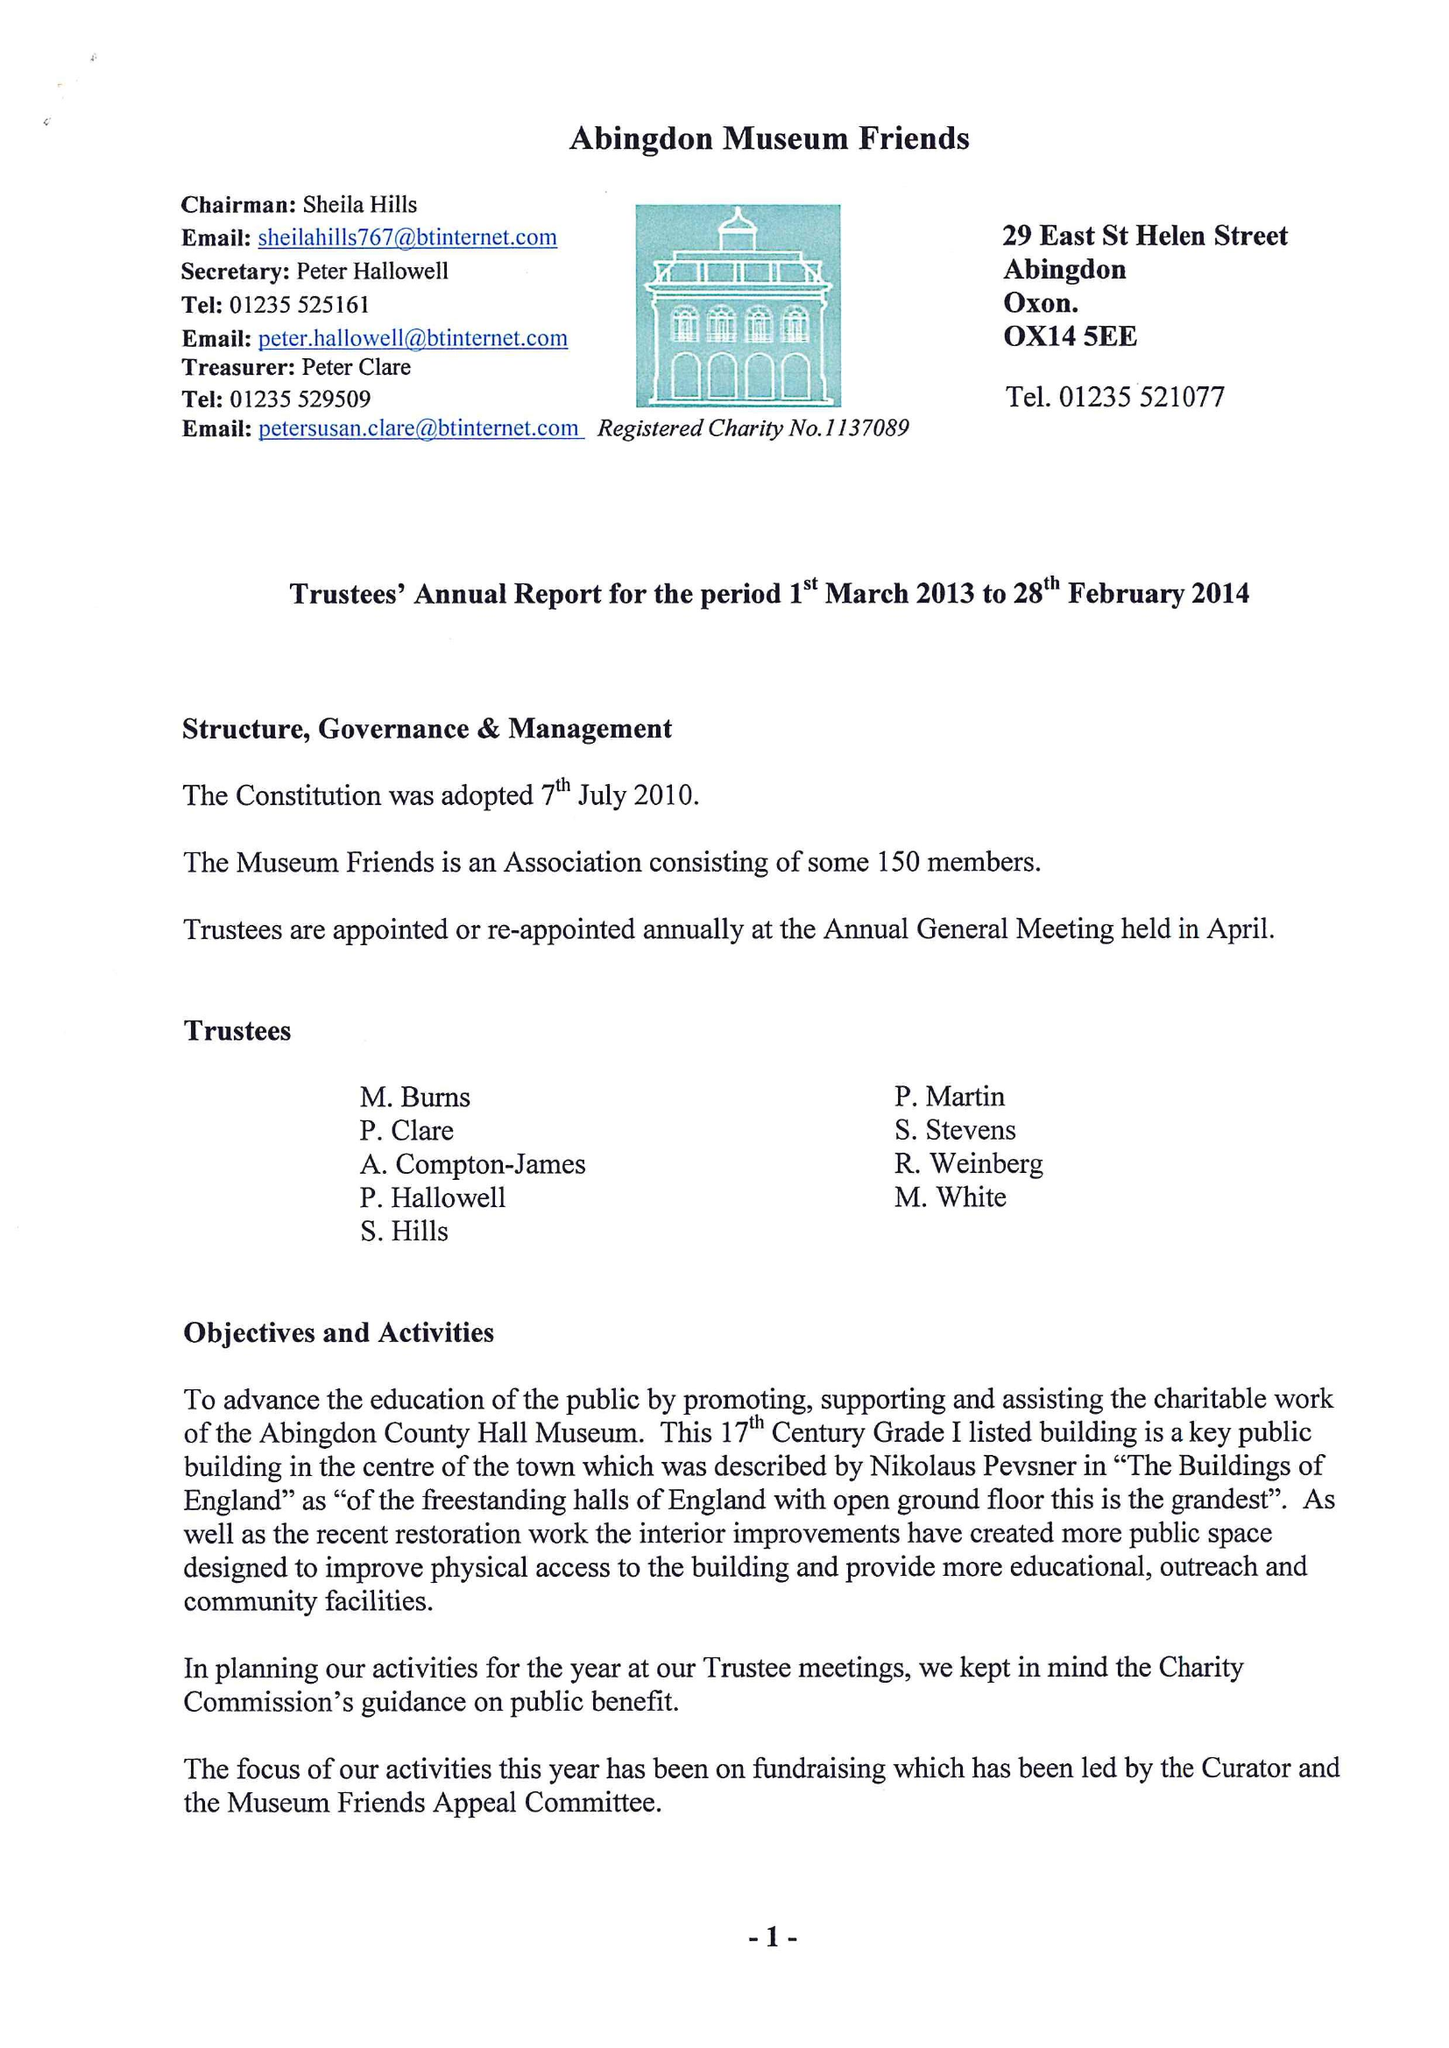What is the value for the report_date?
Answer the question using a single word or phrase. 2014-02-28 